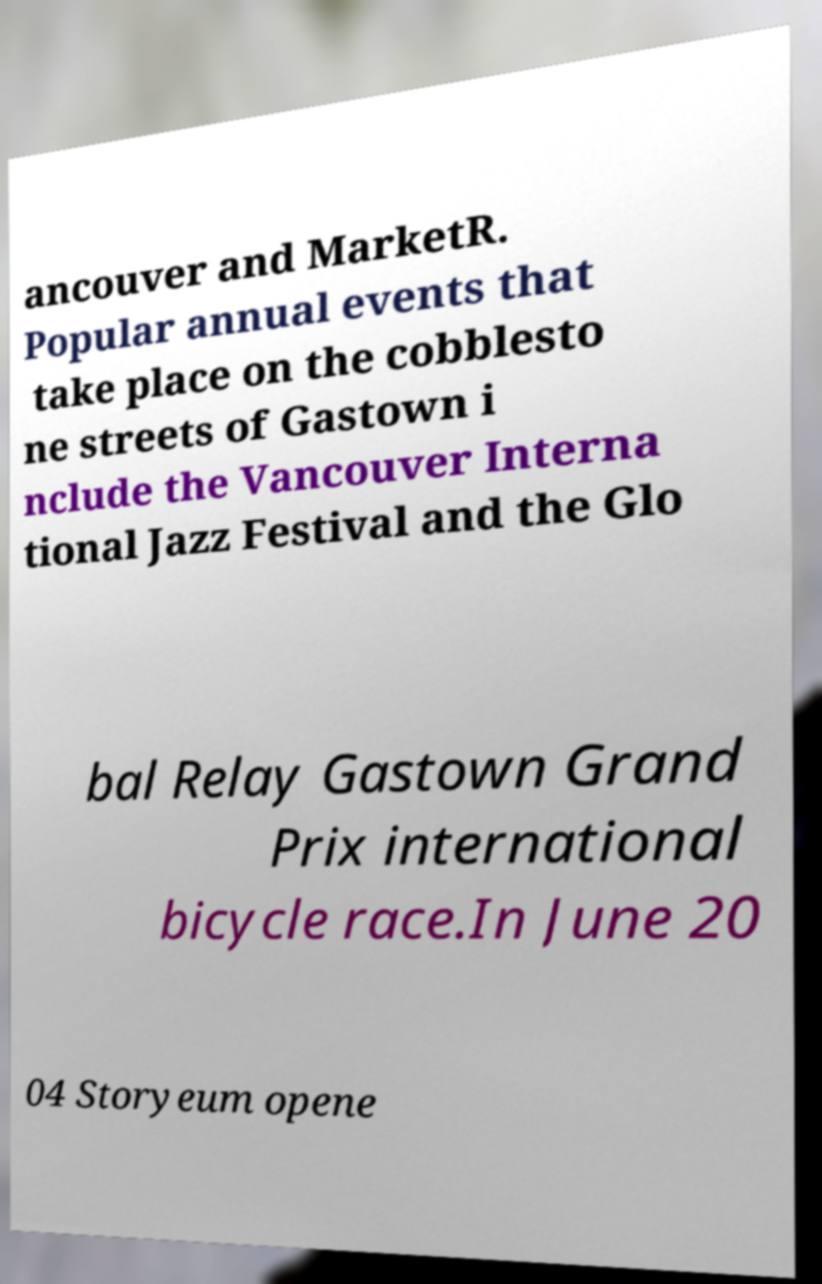For documentation purposes, I need the text within this image transcribed. Could you provide that? ancouver and MarketR. Popular annual events that take place on the cobblesto ne streets of Gastown i nclude the Vancouver Interna tional Jazz Festival and the Glo bal Relay Gastown Grand Prix international bicycle race.In June 20 04 Storyeum opene 